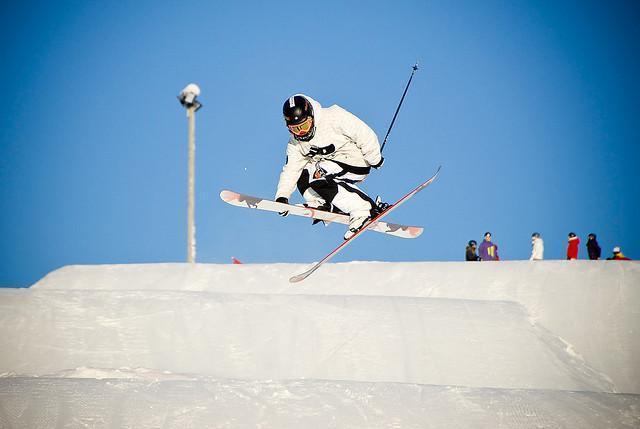How many skiers are in the air?
Give a very brief answer. 1. How many bears are seen to the left of the tree?
Give a very brief answer. 0. 